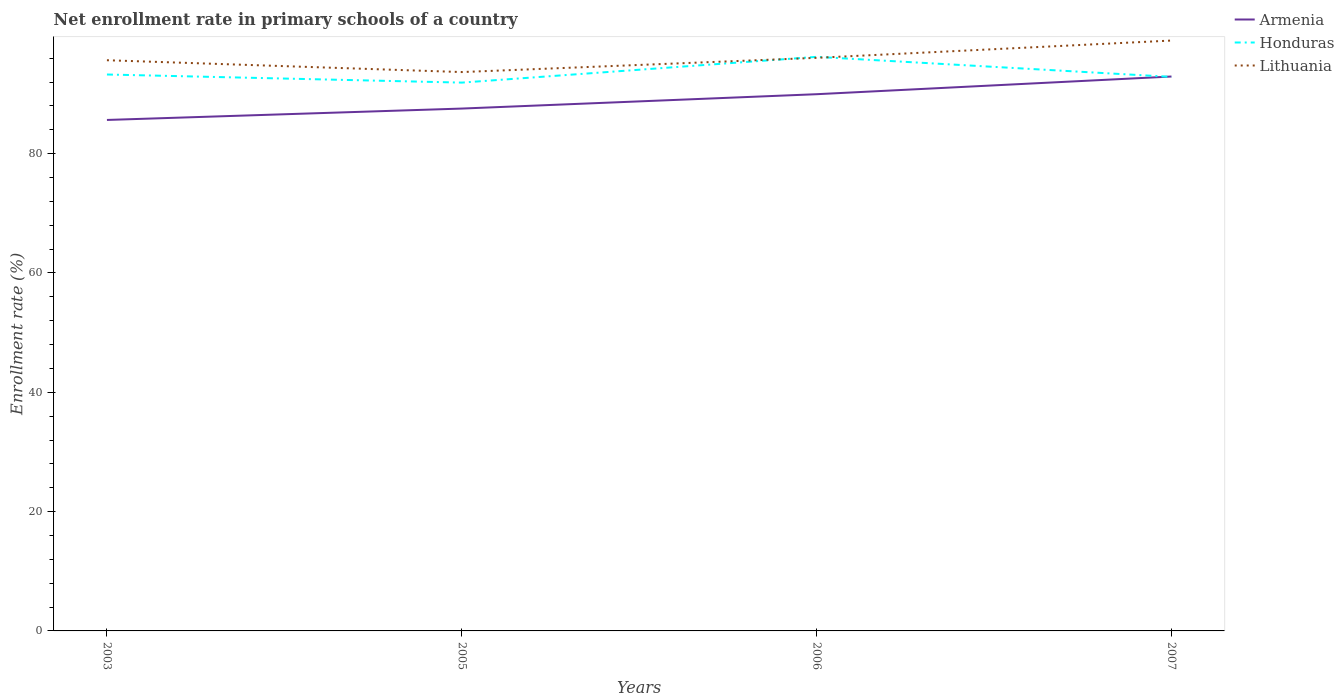How many different coloured lines are there?
Your answer should be compact. 3. Across all years, what is the maximum enrollment rate in primary schools in Honduras?
Make the answer very short. 91.91. What is the total enrollment rate in primary schools in Lithuania in the graph?
Provide a succinct answer. -3.3. What is the difference between the highest and the second highest enrollment rate in primary schools in Armenia?
Keep it short and to the point. 7.28. Is the enrollment rate in primary schools in Honduras strictly greater than the enrollment rate in primary schools in Armenia over the years?
Provide a short and direct response. No. Are the values on the major ticks of Y-axis written in scientific E-notation?
Your answer should be compact. No. Does the graph contain any zero values?
Your answer should be compact. No. Where does the legend appear in the graph?
Your answer should be compact. Top right. How many legend labels are there?
Your answer should be very brief. 3. What is the title of the graph?
Ensure brevity in your answer.  Net enrollment rate in primary schools of a country. Does "Mali" appear as one of the legend labels in the graph?
Your answer should be very brief. No. What is the label or title of the X-axis?
Provide a short and direct response. Years. What is the label or title of the Y-axis?
Your answer should be compact. Enrollment rate (%). What is the Enrollment rate (%) in Armenia in 2003?
Your answer should be very brief. 85.65. What is the Enrollment rate (%) of Honduras in 2003?
Your answer should be compact. 93.27. What is the Enrollment rate (%) of Lithuania in 2003?
Provide a short and direct response. 95.66. What is the Enrollment rate (%) of Armenia in 2005?
Make the answer very short. 87.56. What is the Enrollment rate (%) of Honduras in 2005?
Give a very brief answer. 91.91. What is the Enrollment rate (%) in Lithuania in 2005?
Offer a very short reply. 93.68. What is the Enrollment rate (%) in Armenia in 2006?
Provide a succinct answer. 89.97. What is the Enrollment rate (%) in Honduras in 2006?
Your answer should be very brief. 96.23. What is the Enrollment rate (%) in Lithuania in 2006?
Offer a very short reply. 96.07. What is the Enrollment rate (%) in Armenia in 2007?
Your answer should be very brief. 92.93. What is the Enrollment rate (%) of Honduras in 2007?
Your response must be concise. 92.87. What is the Enrollment rate (%) of Lithuania in 2007?
Provide a short and direct response. 98.96. Across all years, what is the maximum Enrollment rate (%) in Armenia?
Your answer should be very brief. 92.93. Across all years, what is the maximum Enrollment rate (%) in Honduras?
Provide a succinct answer. 96.23. Across all years, what is the maximum Enrollment rate (%) of Lithuania?
Make the answer very short. 98.96. Across all years, what is the minimum Enrollment rate (%) of Armenia?
Your response must be concise. 85.65. Across all years, what is the minimum Enrollment rate (%) in Honduras?
Provide a succinct answer. 91.91. Across all years, what is the minimum Enrollment rate (%) of Lithuania?
Provide a short and direct response. 93.68. What is the total Enrollment rate (%) in Armenia in the graph?
Keep it short and to the point. 356.11. What is the total Enrollment rate (%) of Honduras in the graph?
Ensure brevity in your answer.  374.27. What is the total Enrollment rate (%) in Lithuania in the graph?
Keep it short and to the point. 384.36. What is the difference between the Enrollment rate (%) in Armenia in 2003 and that in 2005?
Ensure brevity in your answer.  -1.91. What is the difference between the Enrollment rate (%) of Honduras in 2003 and that in 2005?
Your response must be concise. 1.36. What is the difference between the Enrollment rate (%) in Lithuania in 2003 and that in 2005?
Give a very brief answer. 1.98. What is the difference between the Enrollment rate (%) in Armenia in 2003 and that in 2006?
Give a very brief answer. -4.32. What is the difference between the Enrollment rate (%) in Honduras in 2003 and that in 2006?
Offer a terse response. -2.96. What is the difference between the Enrollment rate (%) of Lithuania in 2003 and that in 2006?
Your response must be concise. -0.4. What is the difference between the Enrollment rate (%) in Armenia in 2003 and that in 2007?
Your answer should be compact. -7.28. What is the difference between the Enrollment rate (%) of Honduras in 2003 and that in 2007?
Give a very brief answer. 0.4. What is the difference between the Enrollment rate (%) in Lithuania in 2003 and that in 2007?
Provide a short and direct response. -3.3. What is the difference between the Enrollment rate (%) in Armenia in 2005 and that in 2006?
Your answer should be very brief. -2.41. What is the difference between the Enrollment rate (%) of Honduras in 2005 and that in 2006?
Provide a short and direct response. -4.32. What is the difference between the Enrollment rate (%) in Lithuania in 2005 and that in 2006?
Keep it short and to the point. -2.39. What is the difference between the Enrollment rate (%) of Armenia in 2005 and that in 2007?
Provide a short and direct response. -5.37. What is the difference between the Enrollment rate (%) in Honduras in 2005 and that in 2007?
Offer a terse response. -0.96. What is the difference between the Enrollment rate (%) of Lithuania in 2005 and that in 2007?
Keep it short and to the point. -5.28. What is the difference between the Enrollment rate (%) in Armenia in 2006 and that in 2007?
Offer a very short reply. -2.96. What is the difference between the Enrollment rate (%) of Honduras in 2006 and that in 2007?
Offer a terse response. 3.36. What is the difference between the Enrollment rate (%) of Lithuania in 2006 and that in 2007?
Your response must be concise. -2.9. What is the difference between the Enrollment rate (%) of Armenia in 2003 and the Enrollment rate (%) of Honduras in 2005?
Your answer should be very brief. -6.26. What is the difference between the Enrollment rate (%) in Armenia in 2003 and the Enrollment rate (%) in Lithuania in 2005?
Your response must be concise. -8.03. What is the difference between the Enrollment rate (%) of Honduras in 2003 and the Enrollment rate (%) of Lithuania in 2005?
Make the answer very short. -0.41. What is the difference between the Enrollment rate (%) in Armenia in 2003 and the Enrollment rate (%) in Honduras in 2006?
Make the answer very short. -10.58. What is the difference between the Enrollment rate (%) in Armenia in 2003 and the Enrollment rate (%) in Lithuania in 2006?
Keep it short and to the point. -10.41. What is the difference between the Enrollment rate (%) in Honduras in 2003 and the Enrollment rate (%) in Lithuania in 2006?
Offer a terse response. -2.8. What is the difference between the Enrollment rate (%) in Armenia in 2003 and the Enrollment rate (%) in Honduras in 2007?
Give a very brief answer. -7.22. What is the difference between the Enrollment rate (%) in Armenia in 2003 and the Enrollment rate (%) in Lithuania in 2007?
Keep it short and to the point. -13.31. What is the difference between the Enrollment rate (%) of Honduras in 2003 and the Enrollment rate (%) of Lithuania in 2007?
Offer a terse response. -5.69. What is the difference between the Enrollment rate (%) of Armenia in 2005 and the Enrollment rate (%) of Honduras in 2006?
Your answer should be compact. -8.67. What is the difference between the Enrollment rate (%) of Armenia in 2005 and the Enrollment rate (%) of Lithuania in 2006?
Provide a succinct answer. -8.51. What is the difference between the Enrollment rate (%) in Honduras in 2005 and the Enrollment rate (%) in Lithuania in 2006?
Provide a succinct answer. -4.15. What is the difference between the Enrollment rate (%) in Armenia in 2005 and the Enrollment rate (%) in Honduras in 2007?
Provide a succinct answer. -5.31. What is the difference between the Enrollment rate (%) of Armenia in 2005 and the Enrollment rate (%) of Lithuania in 2007?
Provide a short and direct response. -11.4. What is the difference between the Enrollment rate (%) in Honduras in 2005 and the Enrollment rate (%) in Lithuania in 2007?
Make the answer very short. -7.05. What is the difference between the Enrollment rate (%) of Armenia in 2006 and the Enrollment rate (%) of Honduras in 2007?
Provide a succinct answer. -2.9. What is the difference between the Enrollment rate (%) in Armenia in 2006 and the Enrollment rate (%) in Lithuania in 2007?
Offer a terse response. -8.99. What is the difference between the Enrollment rate (%) in Honduras in 2006 and the Enrollment rate (%) in Lithuania in 2007?
Your response must be concise. -2.73. What is the average Enrollment rate (%) of Armenia per year?
Make the answer very short. 89.03. What is the average Enrollment rate (%) in Honduras per year?
Ensure brevity in your answer.  93.57. What is the average Enrollment rate (%) of Lithuania per year?
Offer a very short reply. 96.09. In the year 2003, what is the difference between the Enrollment rate (%) of Armenia and Enrollment rate (%) of Honduras?
Provide a succinct answer. -7.62. In the year 2003, what is the difference between the Enrollment rate (%) of Armenia and Enrollment rate (%) of Lithuania?
Provide a succinct answer. -10.01. In the year 2003, what is the difference between the Enrollment rate (%) in Honduras and Enrollment rate (%) in Lithuania?
Provide a short and direct response. -2.39. In the year 2005, what is the difference between the Enrollment rate (%) in Armenia and Enrollment rate (%) in Honduras?
Offer a very short reply. -4.35. In the year 2005, what is the difference between the Enrollment rate (%) in Armenia and Enrollment rate (%) in Lithuania?
Your answer should be very brief. -6.12. In the year 2005, what is the difference between the Enrollment rate (%) of Honduras and Enrollment rate (%) of Lithuania?
Your response must be concise. -1.77. In the year 2006, what is the difference between the Enrollment rate (%) in Armenia and Enrollment rate (%) in Honduras?
Your response must be concise. -6.26. In the year 2006, what is the difference between the Enrollment rate (%) of Armenia and Enrollment rate (%) of Lithuania?
Offer a very short reply. -6.1. In the year 2006, what is the difference between the Enrollment rate (%) of Honduras and Enrollment rate (%) of Lithuania?
Your answer should be compact. 0.16. In the year 2007, what is the difference between the Enrollment rate (%) in Armenia and Enrollment rate (%) in Honduras?
Provide a succinct answer. 0.07. In the year 2007, what is the difference between the Enrollment rate (%) of Armenia and Enrollment rate (%) of Lithuania?
Your response must be concise. -6.03. In the year 2007, what is the difference between the Enrollment rate (%) in Honduras and Enrollment rate (%) in Lithuania?
Make the answer very short. -6.09. What is the ratio of the Enrollment rate (%) in Armenia in 2003 to that in 2005?
Offer a terse response. 0.98. What is the ratio of the Enrollment rate (%) in Honduras in 2003 to that in 2005?
Keep it short and to the point. 1.01. What is the ratio of the Enrollment rate (%) of Lithuania in 2003 to that in 2005?
Keep it short and to the point. 1.02. What is the ratio of the Enrollment rate (%) of Armenia in 2003 to that in 2006?
Ensure brevity in your answer.  0.95. What is the ratio of the Enrollment rate (%) in Honduras in 2003 to that in 2006?
Provide a succinct answer. 0.97. What is the ratio of the Enrollment rate (%) of Lithuania in 2003 to that in 2006?
Your response must be concise. 1. What is the ratio of the Enrollment rate (%) in Armenia in 2003 to that in 2007?
Offer a terse response. 0.92. What is the ratio of the Enrollment rate (%) of Lithuania in 2003 to that in 2007?
Offer a terse response. 0.97. What is the ratio of the Enrollment rate (%) in Armenia in 2005 to that in 2006?
Your answer should be compact. 0.97. What is the ratio of the Enrollment rate (%) in Honduras in 2005 to that in 2006?
Your answer should be very brief. 0.96. What is the ratio of the Enrollment rate (%) of Lithuania in 2005 to that in 2006?
Keep it short and to the point. 0.98. What is the ratio of the Enrollment rate (%) of Armenia in 2005 to that in 2007?
Provide a short and direct response. 0.94. What is the ratio of the Enrollment rate (%) of Lithuania in 2005 to that in 2007?
Your answer should be very brief. 0.95. What is the ratio of the Enrollment rate (%) in Armenia in 2006 to that in 2007?
Provide a short and direct response. 0.97. What is the ratio of the Enrollment rate (%) in Honduras in 2006 to that in 2007?
Provide a short and direct response. 1.04. What is the ratio of the Enrollment rate (%) in Lithuania in 2006 to that in 2007?
Your answer should be compact. 0.97. What is the difference between the highest and the second highest Enrollment rate (%) of Armenia?
Your answer should be compact. 2.96. What is the difference between the highest and the second highest Enrollment rate (%) of Honduras?
Offer a terse response. 2.96. What is the difference between the highest and the second highest Enrollment rate (%) of Lithuania?
Your response must be concise. 2.9. What is the difference between the highest and the lowest Enrollment rate (%) of Armenia?
Your answer should be compact. 7.28. What is the difference between the highest and the lowest Enrollment rate (%) in Honduras?
Provide a short and direct response. 4.32. What is the difference between the highest and the lowest Enrollment rate (%) of Lithuania?
Provide a short and direct response. 5.28. 